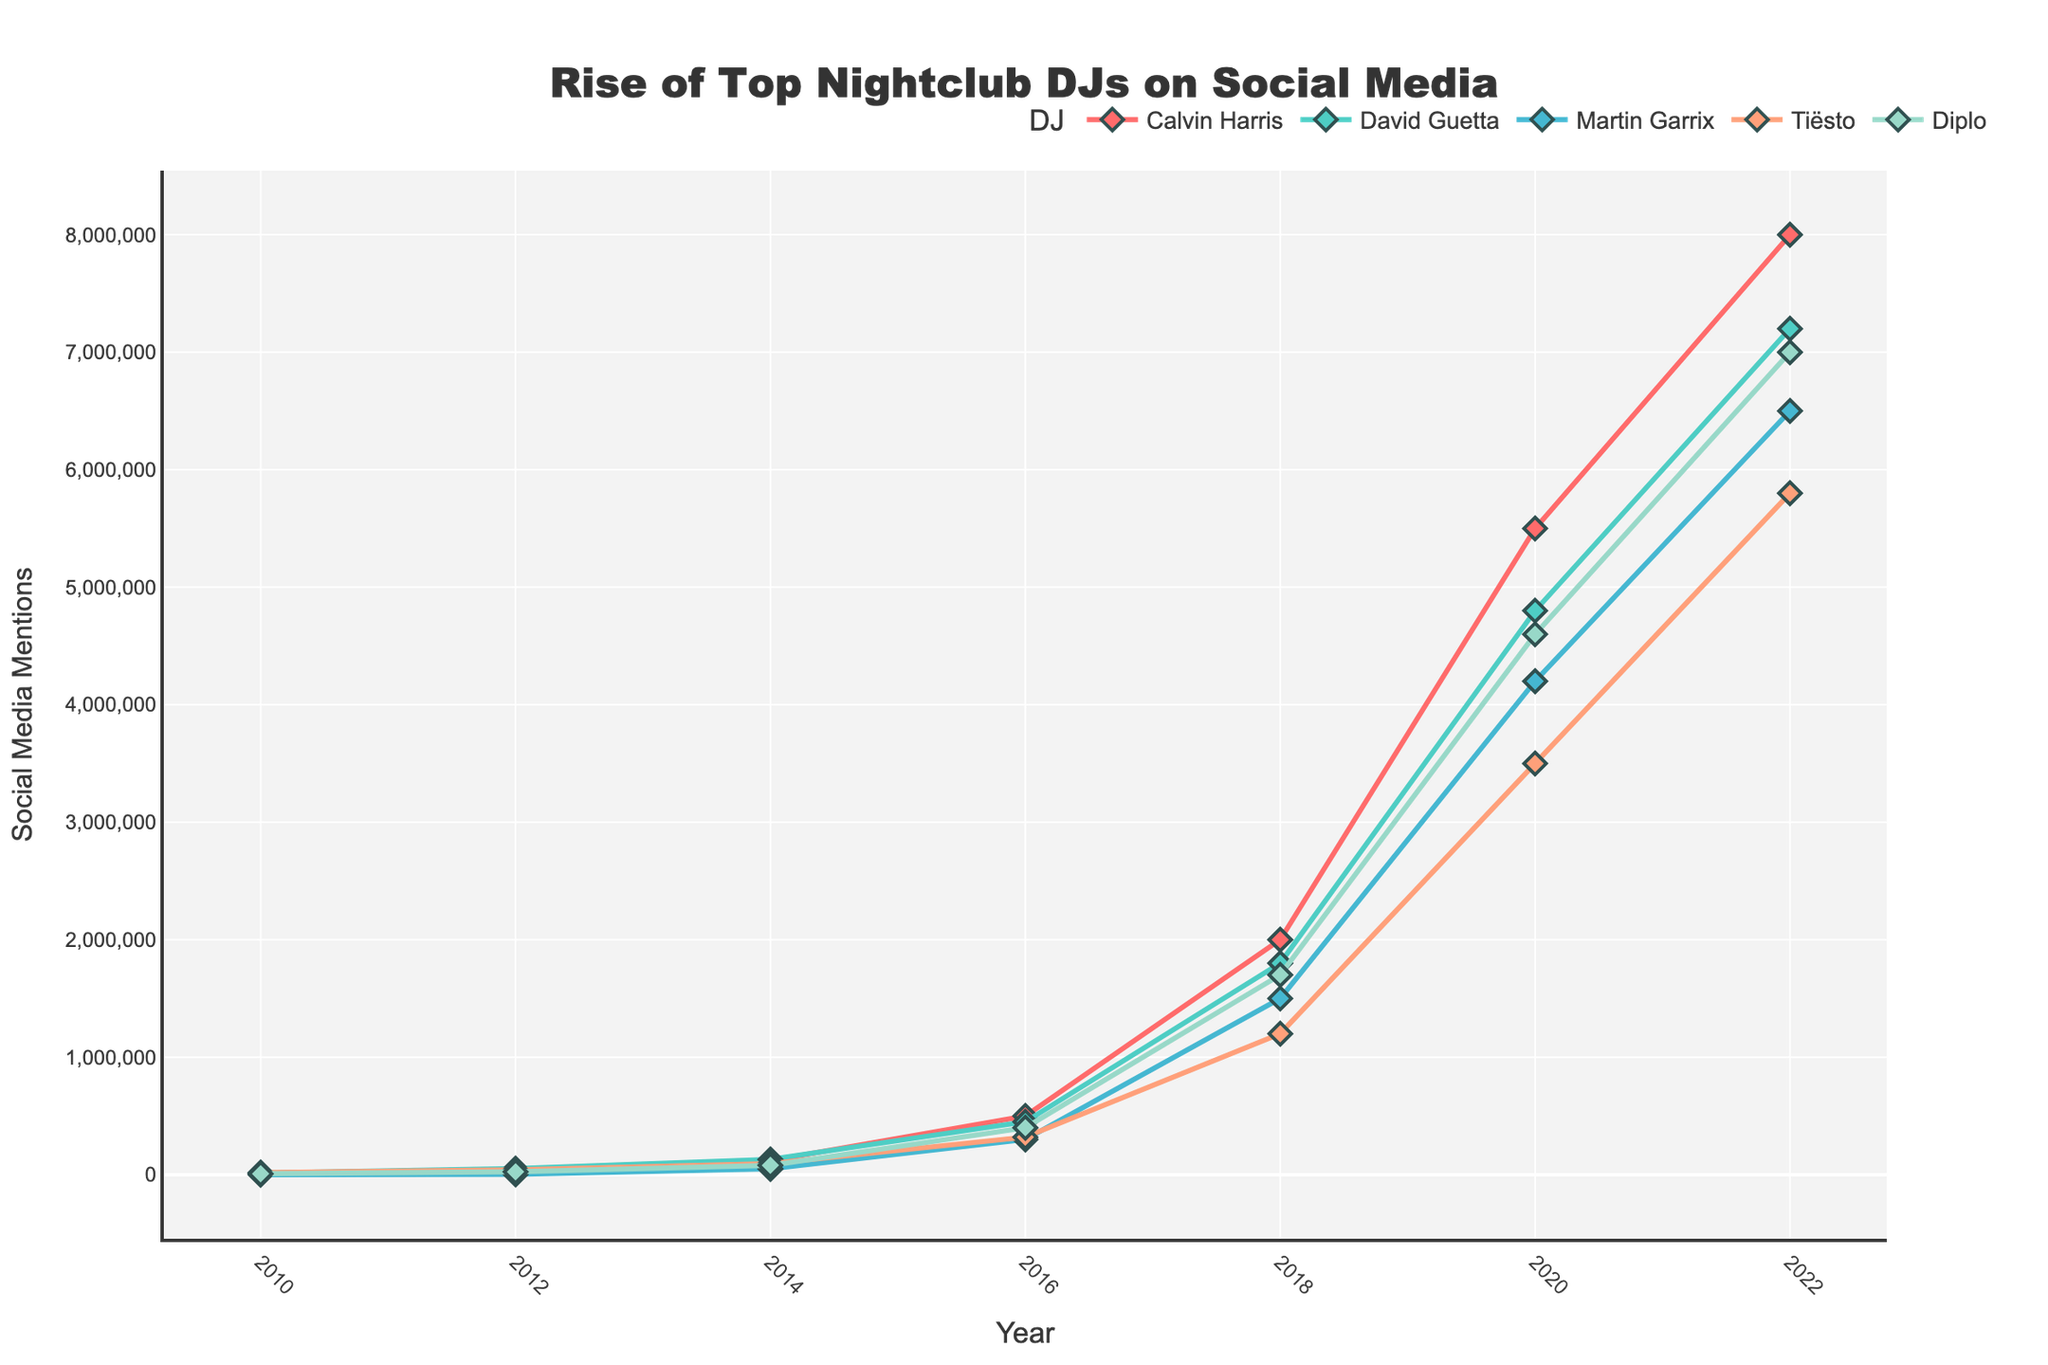What is the total number of social media mentions for Calvin Harris in 2022 and 2020? To find the sum of social media mentions for Calvin Harris in 2022 and 2020, add the mentions from both years: 8,000,000 (2022) + 5,500,000 (2020).
Answer: 13,500,000 How did David Guetta's social media mentions change from 2010 to 2012? To find the change in mentions, subtract the mentions in 2010 from those in 2012: 52,000 (2012) - 15,000 (2010).
Answer: 37,000 Who had more social media mentions in 2016, Martin Garrix or Tiësto? Compare the social media mentions for Martin Garrix and Tiësto in 2016. Martin Garrix had 300,000 mentions, and Tiësto had 320,000.
Answer: Tiësto Which DJ experienced the highest growth in mentions from 2018 to 2020? Calculate the growth for each DJ by subtracting their 2018 mentions from their 2020 mentions. Calvin Harris: 5,500,000 - 2,000,000 = 3,500,000; David Guetta: 4,800,000 - 1,800,000 = 3,000,000; Martin Garrix: 4,200,000 - 1,500,000 = 2,700,000; Tiësto: 3,500,000 - 1,200,000 = 2,300,000; Diplo: 4,600,000 - 1,700,000 = 2,900,000.
Answer: Calvin Harris What's the average number of social media mentions for Diplo across all years presented? To find the average, sum the social media mentions for Diplo across all years and divide by the number of years: (8,000 + 25,000 + 80,000 + 400,000 + 1,700,000 + 4,600,000 + 7,000,000) / 7 = 1,830,714.
Answer: 1,830,714 Did any DJ reach more than 1 million mentions by 2016? By 2016, check if any DJ has more than 1 million mentions. 2016 data shows Calvin Harris: 500,000, David Guetta: 450,000, Martin Garrix: 300,000, Tiësto: 320,000, Diplo: 400,000.
Answer: No What's the difference in social media mentions between the highest and lowest DJ in 2014? Find the highest and lowest mentions in 2014. Highest: David Guetta with 130,000, Lowest: Martin Garrix with 50,000. Calculate the difference: 130,000 - 50,000.
Answer: 80,000 